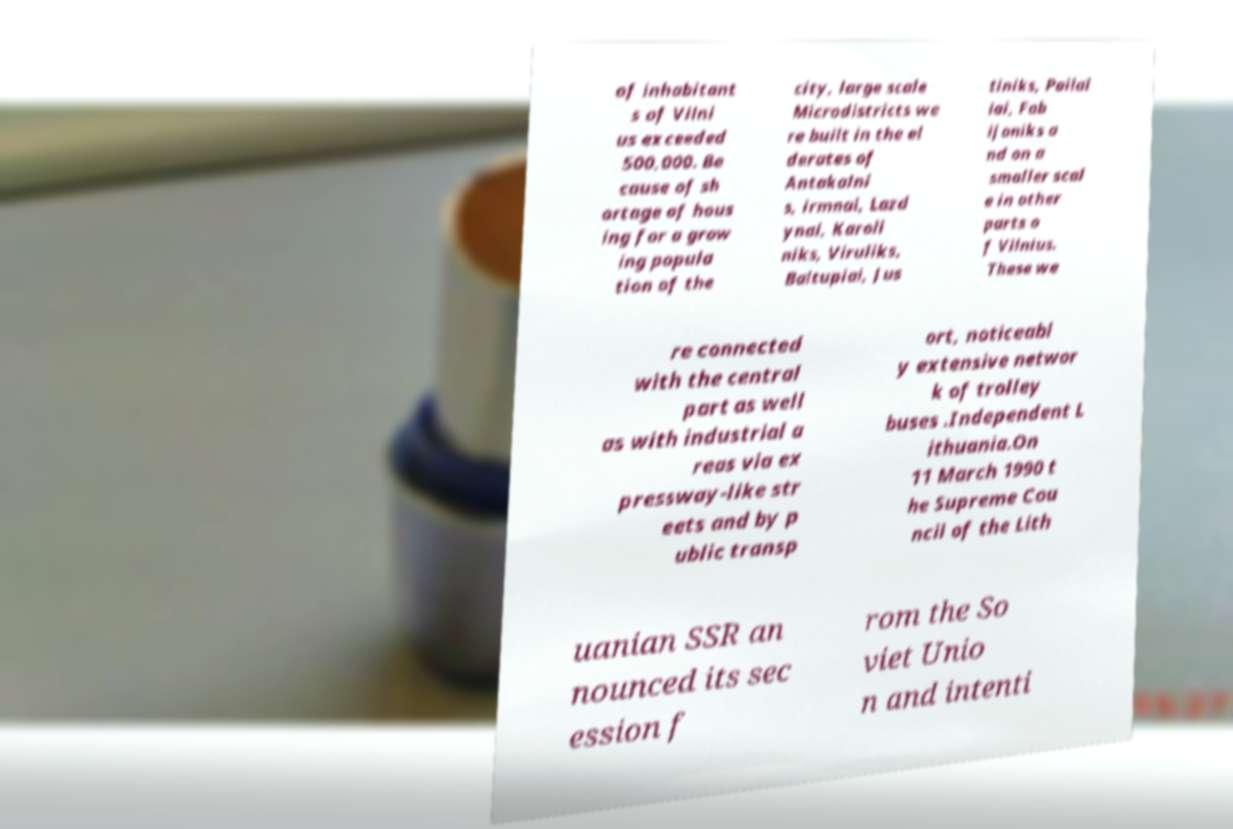For documentation purposes, I need the text within this image transcribed. Could you provide that? of inhabitant s of Vilni us exceeded 500,000. Be cause of sh ortage of hous ing for a grow ing popula tion of the city, large scale Microdistricts we re built in the el derates of Antakalni s, irmnai, Lazd ynai, Karoli niks, Viruliks, Baltupiai, Jus tiniks, Pailai iai, Fab ijoniks a nd on a smaller scal e in other parts o f Vilnius. These we re connected with the central part as well as with industrial a reas via ex pressway-like str eets and by p ublic transp ort, noticeabl y extensive networ k of trolley buses .Independent L ithuania.On 11 March 1990 t he Supreme Cou ncil of the Lith uanian SSR an nounced its sec ession f rom the So viet Unio n and intenti 